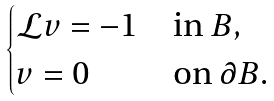Convert formula to latex. <formula><loc_0><loc_0><loc_500><loc_500>\begin{cases} \mathcal { L } v = - 1 & \text {in } B , \\ v = 0 & \text {on } \partial B . \end{cases}</formula> 